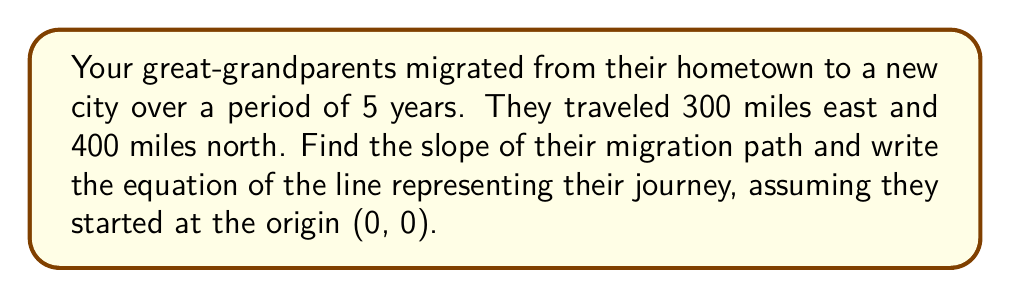Give your solution to this math problem. 1. Identify the points:
   Start point: (0, 0)
   End point: (300, 400)

2. Calculate the slope using the slope formula:
   $m = \frac{y_2 - y_1}{x_2 - x_1} = \frac{400 - 0}{300 - 0} = \frac{400}{300} = \frac{4}{3}$

3. Use the point-slope form of a line equation:
   $y - y_1 = m(x - x_1)$

4. Substitute the slope and the starting point (0, 0):
   $y - 0 = \frac{4}{3}(x - 0)$

5. Simplify to get the equation in slope-intercept form:
   $y = \frac{4}{3}x$
Answer: Slope: $\frac{4}{3}$; Equation: $y = \frac{4}{3}x$ 